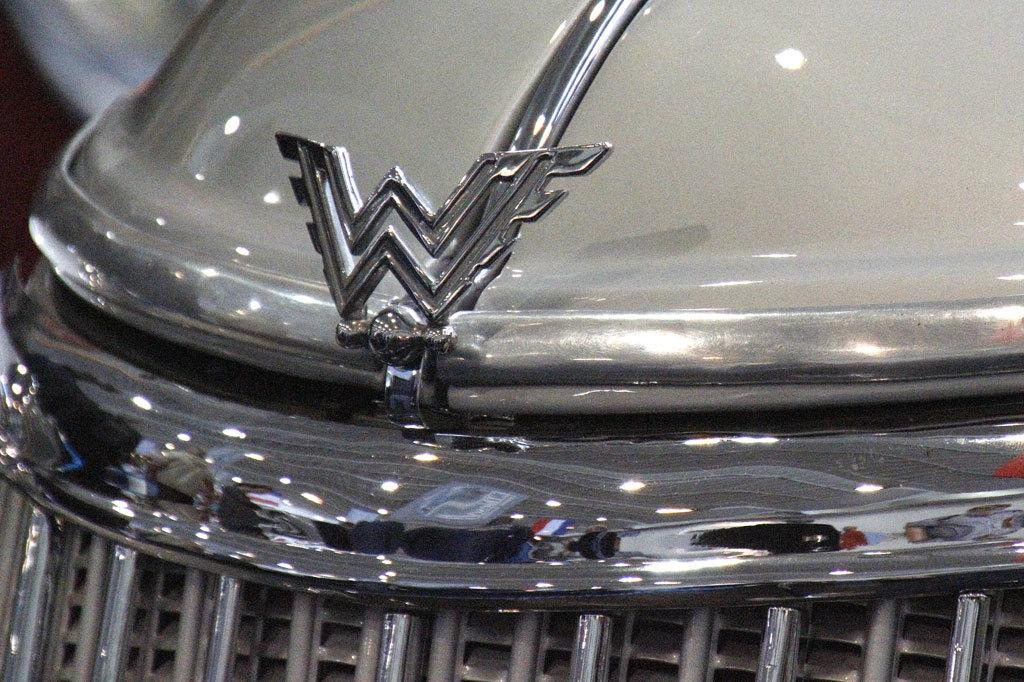What part of a vehicle can be seen in the image? The front bumper of a car is visible in the image. Can you identify any specific features of the car? Yes, the logo of the company is present on the car. Are there any pets visible in the image? No, there are no pets present in the image. Can you see a nest in the image? No, there is no nest visible in the image. 